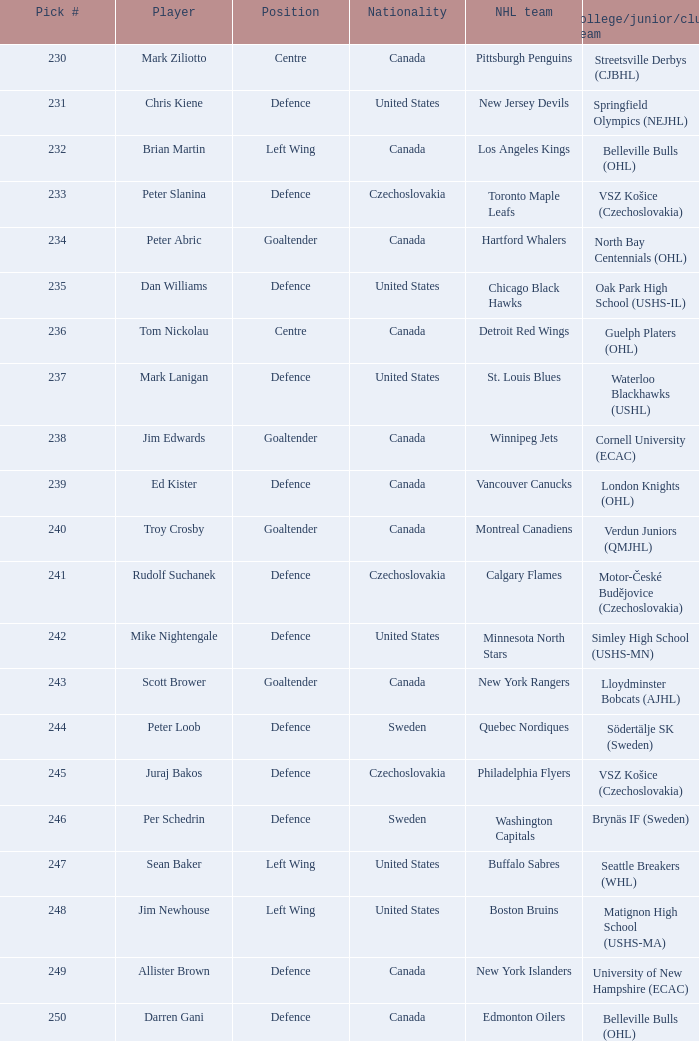To which group does the winnipeg jets belong to? Cornell University (ECAC). 